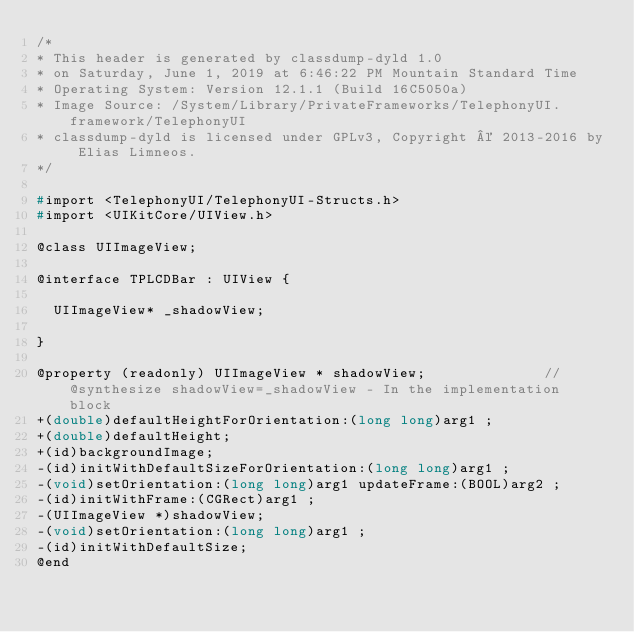<code> <loc_0><loc_0><loc_500><loc_500><_C_>/*
* This header is generated by classdump-dyld 1.0
* on Saturday, June 1, 2019 at 6:46:22 PM Mountain Standard Time
* Operating System: Version 12.1.1 (Build 16C5050a)
* Image Source: /System/Library/PrivateFrameworks/TelephonyUI.framework/TelephonyUI
* classdump-dyld is licensed under GPLv3, Copyright © 2013-2016 by Elias Limneos.
*/

#import <TelephonyUI/TelephonyUI-Structs.h>
#import <UIKitCore/UIView.h>

@class UIImageView;

@interface TPLCDBar : UIView {

	UIImageView* _shadowView;

}

@property (readonly) UIImageView * shadowView;              //@synthesize shadowView=_shadowView - In the implementation block
+(double)defaultHeightForOrientation:(long long)arg1 ;
+(double)defaultHeight;
+(id)backgroundImage;
-(id)initWithDefaultSizeForOrientation:(long long)arg1 ;
-(void)setOrientation:(long long)arg1 updateFrame:(BOOL)arg2 ;
-(id)initWithFrame:(CGRect)arg1 ;
-(UIImageView *)shadowView;
-(void)setOrientation:(long long)arg1 ;
-(id)initWithDefaultSize;
@end

</code> 